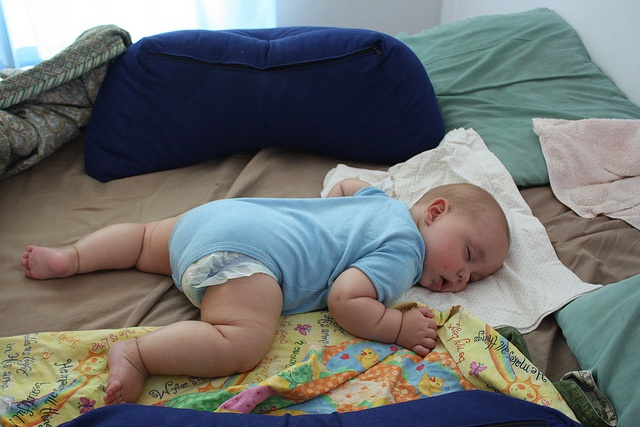Describe the objects in this image and their specific colors. I can see bed in lightblue, black, gray, darkgray, and teal tones and people in lightblue, gray, and darkgray tones in this image. 